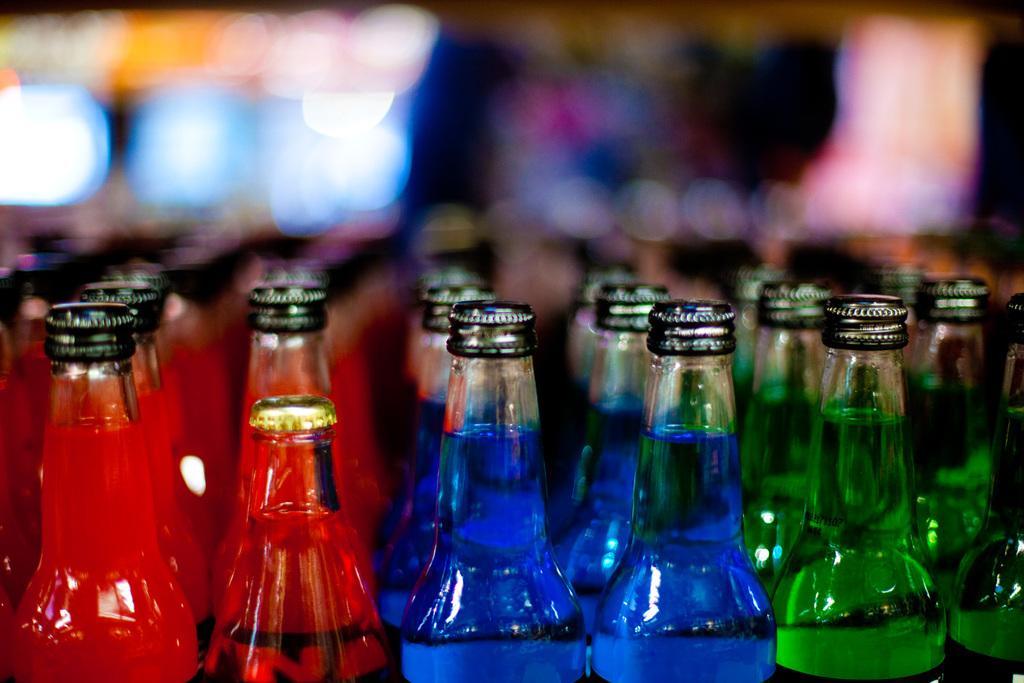How would you summarize this image in a sentence or two? This picture shows bunch of bottles with liquid in it 